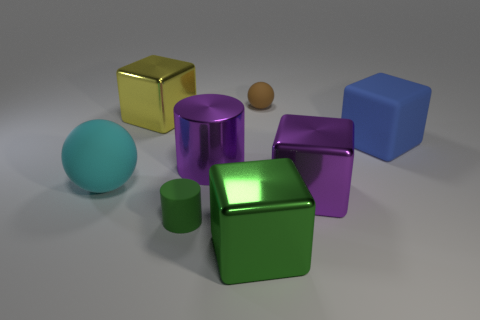Subtract all brown cubes. Subtract all gray spheres. How many cubes are left? 4 Add 2 large matte blocks. How many objects exist? 10 Subtract all balls. How many objects are left? 6 Subtract 0 gray balls. How many objects are left? 8 Subtract all small green objects. Subtract all tiny green cylinders. How many objects are left? 6 Add 4 purple cylinders. How many purple cylinders are left? 5 Add 8 metal cylinders. How many metal cylinders exist? 9 